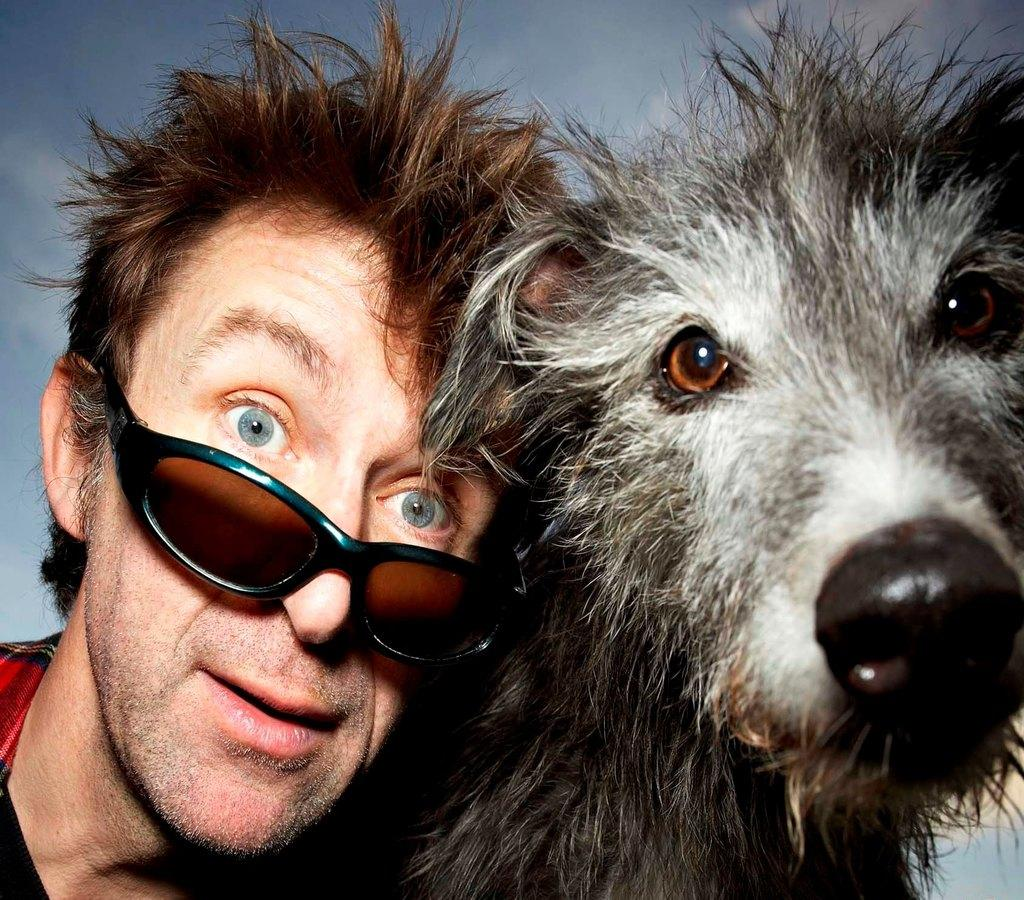Who is present in the image? There is a man in the image. What other living creature can be seen in the image? There is a dog in the image. What type of flame can be seen coming from the dog's mouth in the image? There is no flame present in the image, and the dog's mouth is not depicted as emitting any flames. 